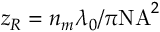<formula> <loc_0><loc_0><loc_500><loc_500>z _ { R } = n _ { m } \lambda _ { 0 } / \pi N A ^ { 2 }</formula> 